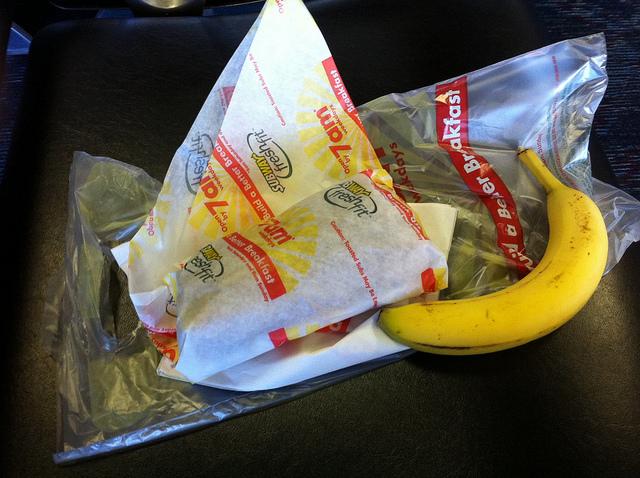Is this a healthy snack?
Give a very brief answer. Yes. Is there a wrapped sandwich next to the banana?
Quick response, please. Yes. What shape is the napkin?
Quick response, please. Square. 